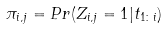Convert formula to latex. <formula><loc_0><loc_0><loc_500><loc_500>\pi _ { i , j } = P r ( Z _ { i , j } = 1 | t _ { 1 \colon i } )</formula> 